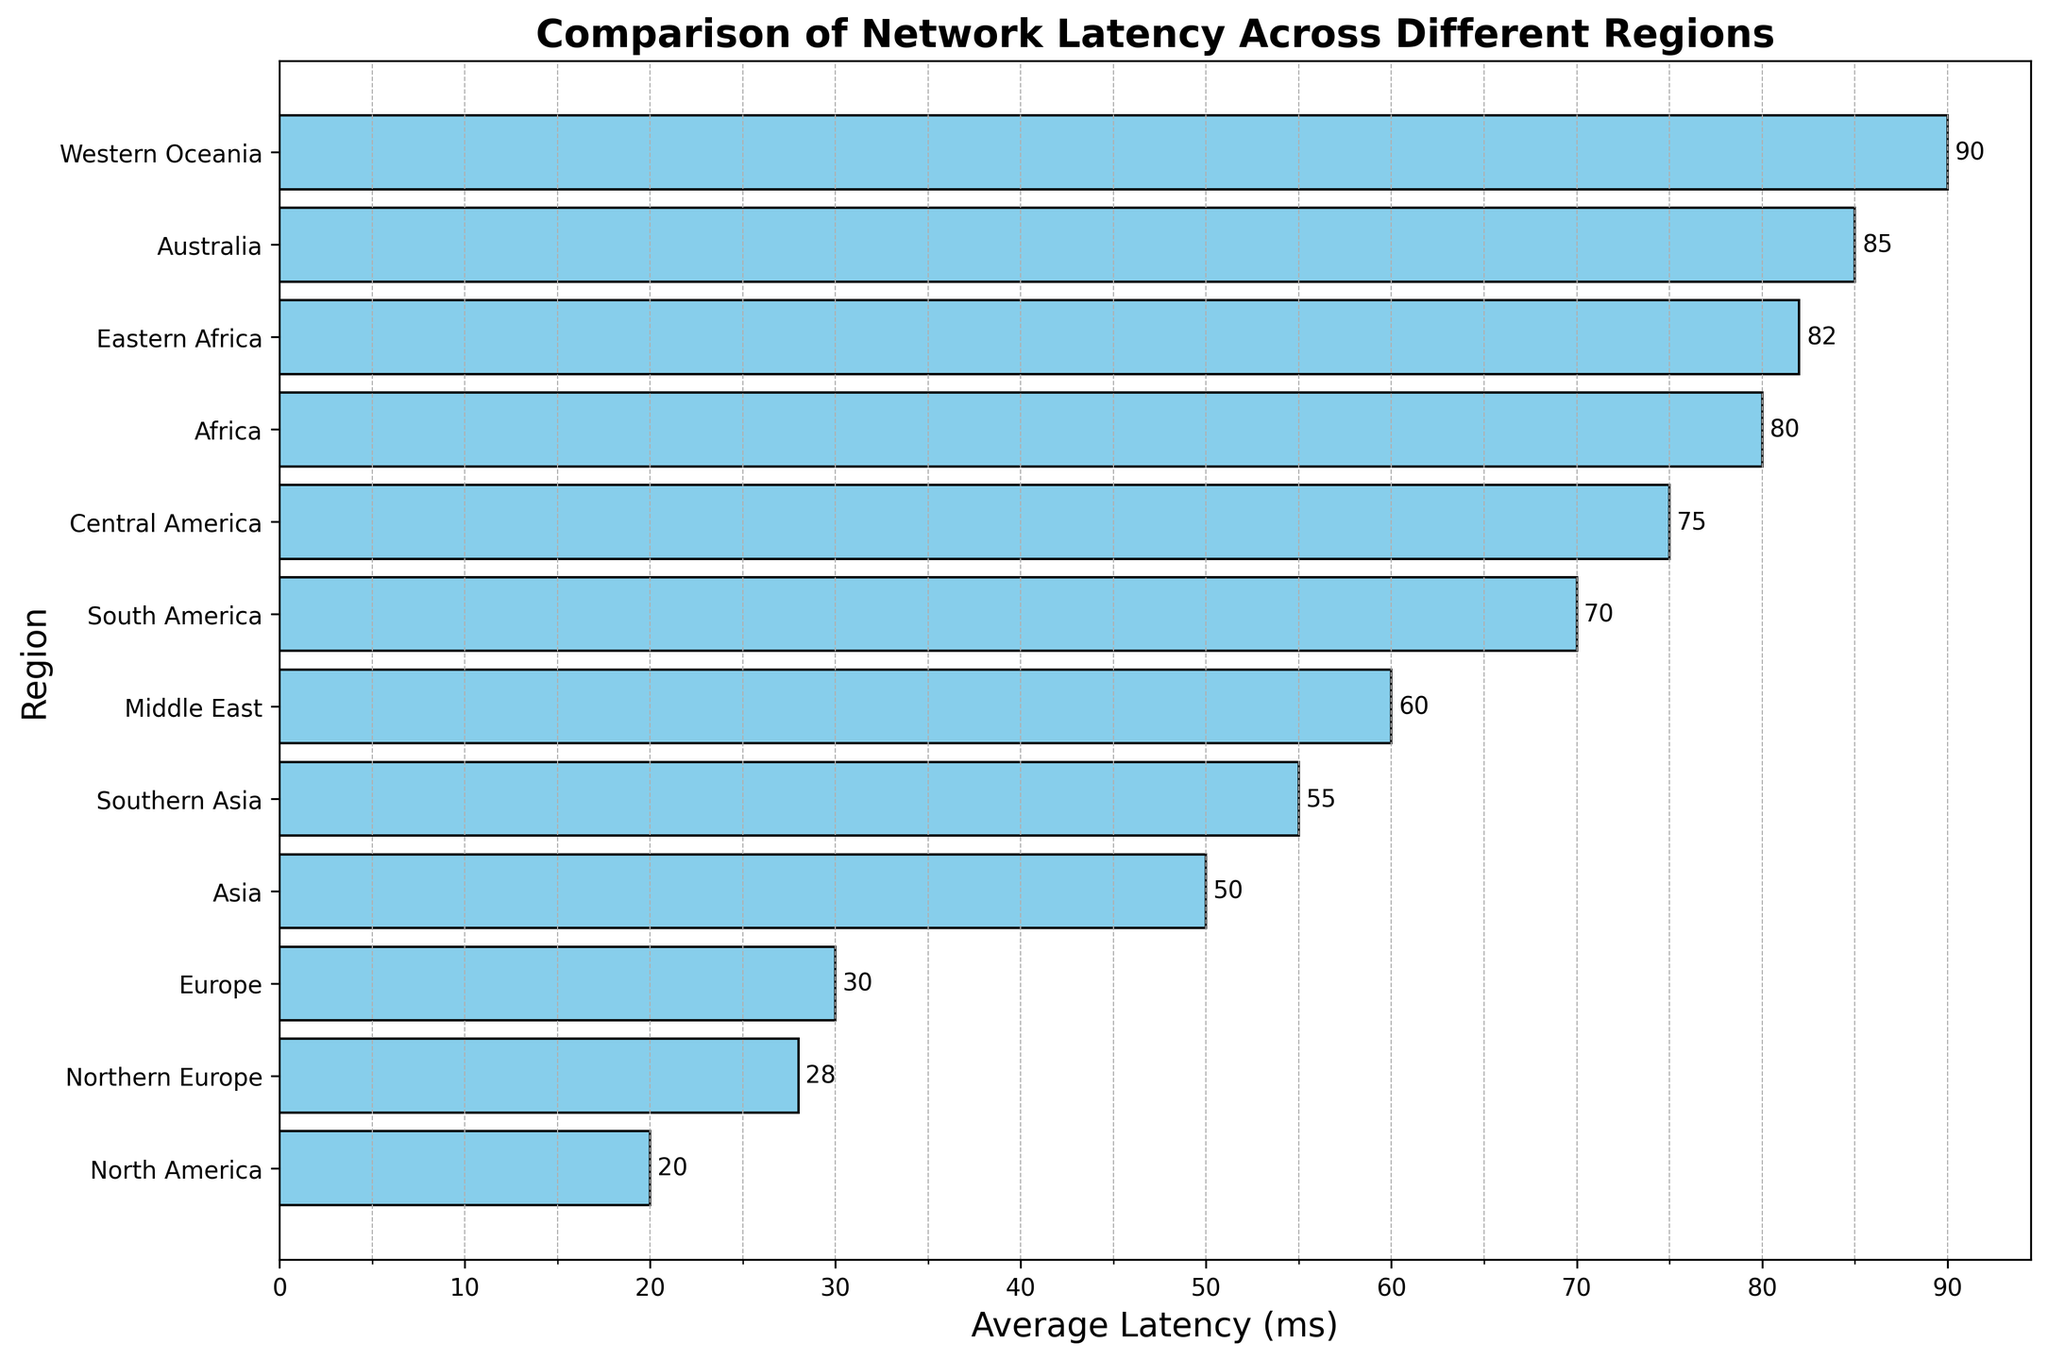What's the region with the highest average latency? The bar representing Western Oceania has the highest value.
Answer: Western Oceania What's the average latency difference between Europe and Asia? The average latency in Europe is 30 ms, and in Asia, it is 50 ms. The difference is 50 - 30 = 20 ms.
Answer: 20 ms Which region has a lower average latency: Africa or Central America? The average latency in Africa is 80 ms, whereas Central America's is 75 ms. 75 ms < 80 ms.
Answer: Central America How does the latency in Southern Asia compare to Northern Europe? The average latency in Southern Asia is 55 ms, and in Northern Europe, it is 28 ms. 55 ms > 28 ms.
Answer: Southern Asia has higher latency Identify the region with the third highest average latency. The third highest average latency is observed in Central America with 75 ms.
Answer: Central America Which regions have an average latency below 30 ms? North America (20 ms) and Northern Europe (28 ms) have average latencies below 30 ms.
Answer: North America, Northern Europe Is the average latency of South America more than twice that of North America? The average latency in South America is 70 ms, and in North America, it is 20 ms. 2 * 20 ms = 40 ms. 70 ms > 40 ms, so yes.
Answer: Yes What is the combined average latency of the Middle East and Eastern Africa? The average latency of the Middle East is 60 ms, and Eastern Africa is 82 ms. Combined, it is 60 + 82 = 142 ms.
Answer: 142 ms What is the visual difference between the region with the lowest latency and the highest latency? The bar for North America (lowest latency: 20 ms) is much shorter compared to the bar for Western Oceania (highest latency: 90 ms).
Answer: The bar for North America is much shorter than Western Oceania How does latency in Australia compare visually to Africa? The bar for Australia (85 ms) is slightly taller than the bar for Africa (80 ms).
Answer: Australia's bar is slightly taller 